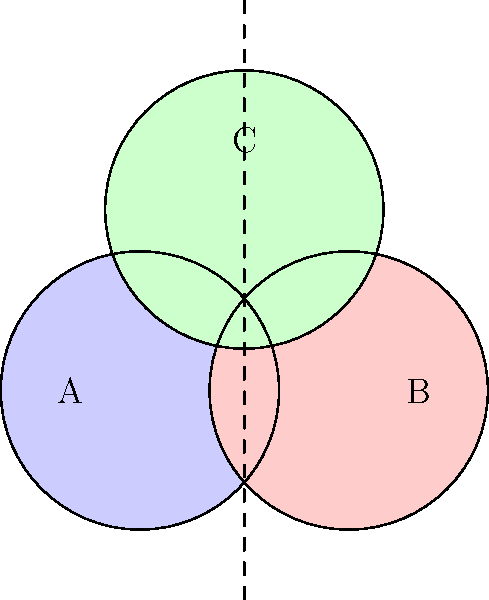In the diagram, three overlapping trade zones (A, B, and C) are represented. If a product is manufactured in the region where all three zones intersect, how many different zone classifications could potentially apply to this product for trade purposes? To determine the number of potential zone classifications, we need to analyze the overlapping regions in the diagram:

1. Identify the region where all three zones intersect:
   This is the central area where circles A, B, and C overlap.

2. Count the number of zones that cover this intersection:
   - Zone A covers this area
   - Zone B covers this area
   - Zone C covers this area

3. Consider all possible combinations:
   - The product could be classified as belonging to zone A only
   - The product could be classified as belonging to zone B only
   - The product could be classified as belonging to zone C only
   - The product could be classified as belonging to zones A and B
   - The product could be classified as belonging to zones A and C
   - The product could be classified as belonging to zones B and C
   - The product could be classified as belonging to all three zones A, B, and C

4. Count the total number of possible classifications:
   There are 7 distinct possibilities (3 single-zone, 3 double-zone, and 1 triple-zone classification).

Therefore, a product manufactured in the region where all three zones intersect could potentially have 7 different zone classifications for trade purposes.
Answer: 7 